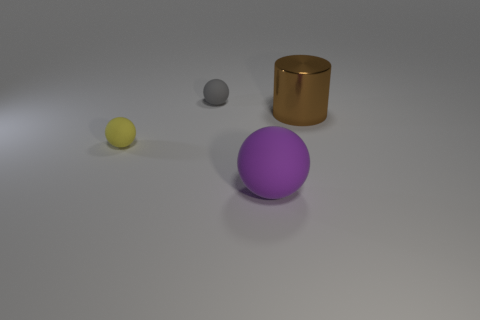Subtract all tiny matte balls. How many balls are left? 1 Subtract all purple balls. How many balls are left? 2 Subtract 3 balls. How many balls are left? 0 Subtract all balls. How many objects are left? 1 Subtract all yellow cylinders. How many blue spheres are left? 0 Add 4 gray spheres. How many objects exist? 8 Add 3 purple blocks. How many purple blocks exist? 3 Subtract 1 yellow spheres. How many objects are left? 3 Subtract all yellow spheres. Subtract all cyan cylinders. How many spheres are left? 2 Subtract all gray metallic cylinders. Subtract all big purple spheres. How many objects are left? 3 